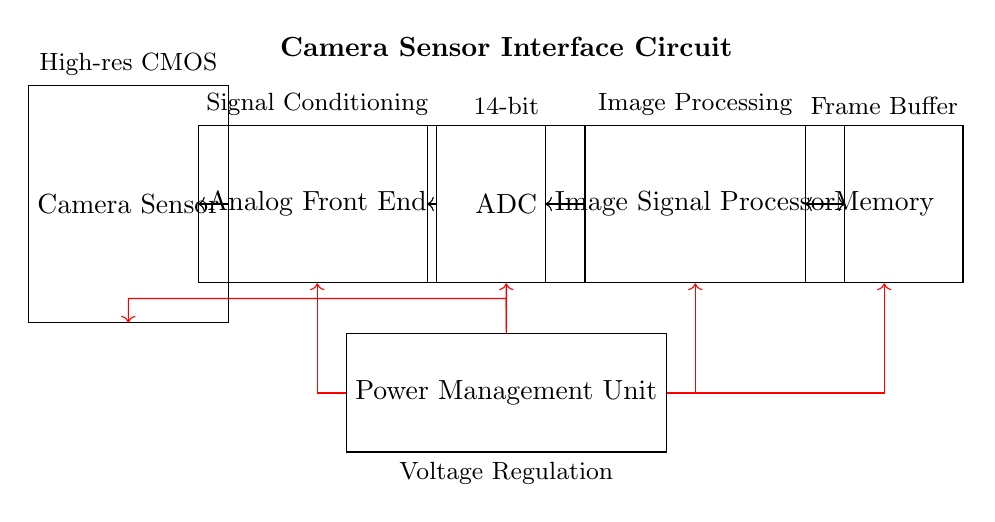what is the component that captures images? The component labeled "Camera Sensor" is responsible for capturing images in this circuit. It is the first block in the signal flow and is essential for the image acquisition process.
Answer: Camera Sensor what does AFE stand for? The label "AFE" stands for Analog Front End, which is a component that conditions the signal coming from the camera sensor before it is converted by the ADC.
Answer: Analog Front End what is the bit depth of the ADC in this circuit? The circuit specifies that the ADC has a "14-bit" designation, indicating the level of precision it can achieve when converting the analog signal to digital form.
Answer: 14-bit how does the processed image data move in the circuit? The image data flows sequentially from the sensor to the AFE, then to the ADC, and finally to the ISP. This path shows how each component processes the image data before it reaches memory for storage.
Answer: Sensor to AFE to ADC to ISP what is the role of the image signal processor in this circuit? The Image Signal Processor (ISP) is specifically designed to improve the quality of the captured images through various processing techniques, such as filtering, noise reduction, and enhancement before storing it.
Answer: Image Processing which component regulates voltage in this circuit? The "Power Management Unit" is labeled in the diagram as the component responsible for regulating the voltage supplied to the other parts of the circuit, ensuring proper operation.
Answer: Power Management Unit how does the memory interface with the ISP? The memory has a bi-directional connection with the ISP, indicated by the double-headed arrow, allowing it to both receive processed data from the ISP and send data back to it, as needed.
Answer: Bi-directional connection 